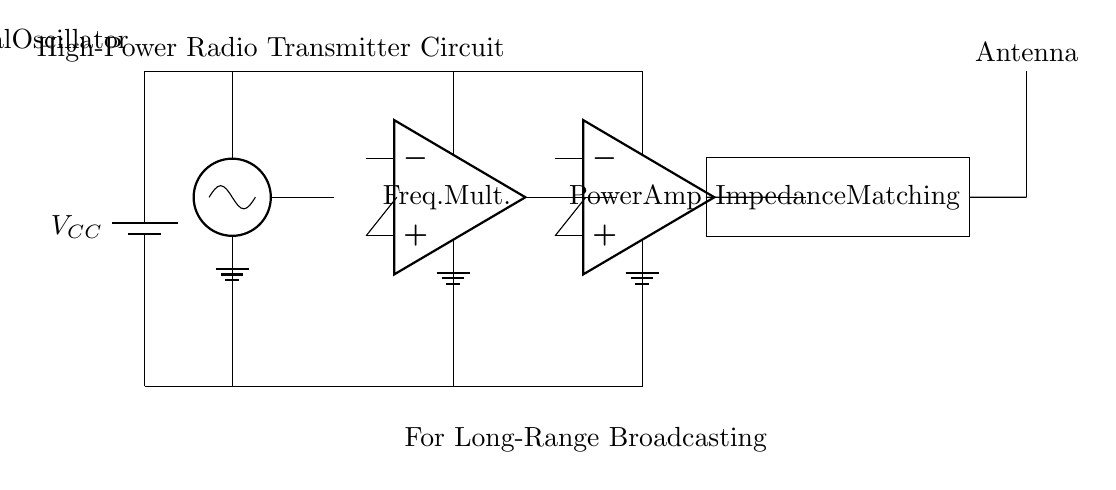What is the power supply voltage in this circuit? The voltage is indicated as VCC on the battery. Typically, VCC refers to the supply voltage, but the exact value isn't specified in the circuit diagram.
Answer: VCC What component is used to generate the initial signal? The component that generates the initial signal in the circuit is labeled as a Crystal Oscillator, which is designed to produce a stable frequency signal needed to drive the subsequent stages.
Answer: Crystal Oscillator What is the purpose of the frequency multiplier? The frequency multiplier's role is to increase the frequency of the signal coming from the oscillator before amplification, allowing the output signal to reach the desired frequency for radio transmission.
Answer: Increase frequency Which component acts as the final stage of amplification? The last amplification stage is handled by the Power Amplifier, which is responsible for boosting the signal strength before it is sent to the antenna for transmission.
Answer: Power Amplifier How does the signal flow from the oscillator to the antenna? The signal flows from the oscillator to the frequency multiplier, then to the power amplifier, followed by passing through the impedance matching network, before finally reaching the antenna, ensuring efficient transmission.
Answer: Oscillator → Frequency Multiplier → Power Amplifier → Impedance Matching → Antenna What is the function of the impedance matching network? The impedance matching network is employed to match the output impedance of the power amplifier to the impedance of the antenna, maximizing power transfer and minimizing reflections in the transmission line.
Answer: Match impedances 